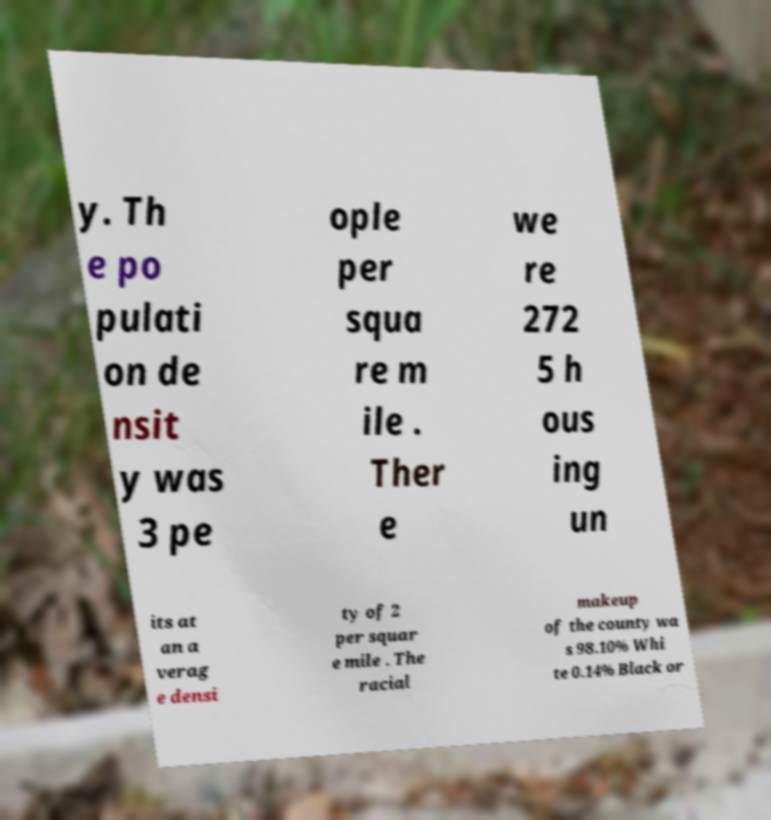What messages or text are displayed in this image? I need them in a readable, typed format. y. Th e po pulati on de nsit y was 3 pe ople per squa re m ile . Ther e we re 272 5 h ous ing un its at an a verag e densi ty of 2 per squar e mile . The racial makeup of the county wa s 98.10% Whi te 0.14% Black or 